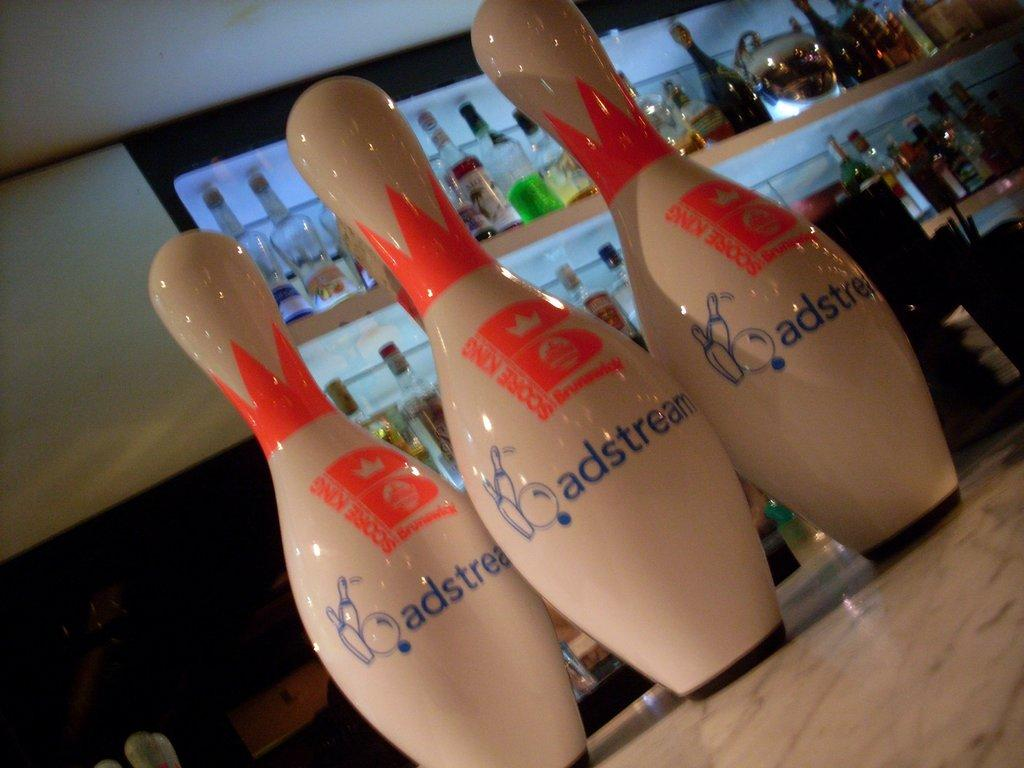<image>
Render a clear and concise summary of the photo. a few pins that say ad stream on them 